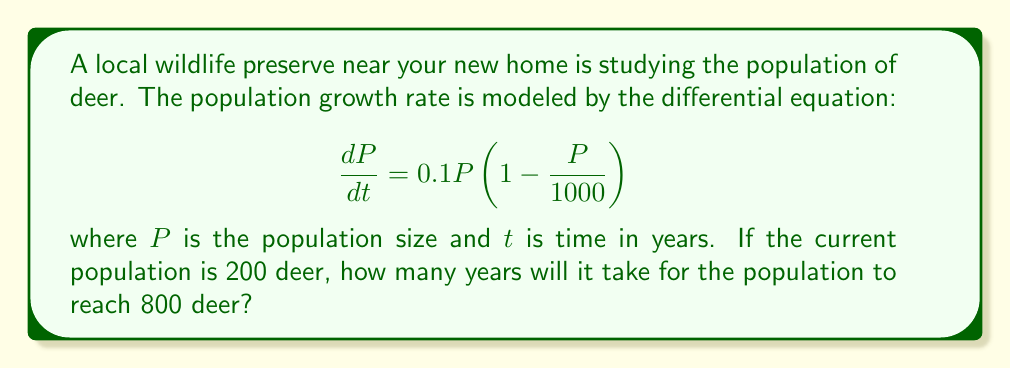Can you solve this math problem? 1) We need to solve this differential equation with the given initial condition and find the time when P = 800.

2) The given equation is a logistic growth model. Its solution is:

   $$P(t) = \frac{K}{1 + \left(\frac{K}{P_0} - 1\right)e^{-rt}}$$

   where K is the carrying capacity (1000), r is the growth rate (0.1), and P_0 is the initial population (200).

3) Substituting these values:

   $$P(t) = \frac{1000}{1 + \left(\frac{1000}{200} - 1\right)e^{-0.1t}}$$

4) We want to find t when P(t) = 800. Let's set up the equation:

   $$800 = \frac{1000}{1 + 4e^{-0.1t}}$$

5) Solve for t:
   
   $$1 + 4e^{-0.1t} = \frac{1000}{800} = 1.25$$
   
   $$4e^{-0.1t} = 0.25$$
   
   $$e^{-0.1t} = 0.0625$$
   
   $$-0.1t = \ln(0.0625) = -2.7726$$
   
   $$t = 27.726$$

6) Therefore, it will take approximately 27.73 years for the population to reach 800 deer.
Answer: 27.73 years 